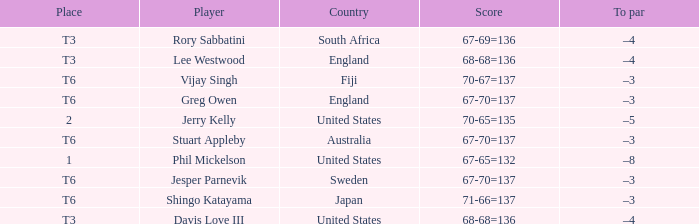Name the score for vijay singh 70-67=137. 